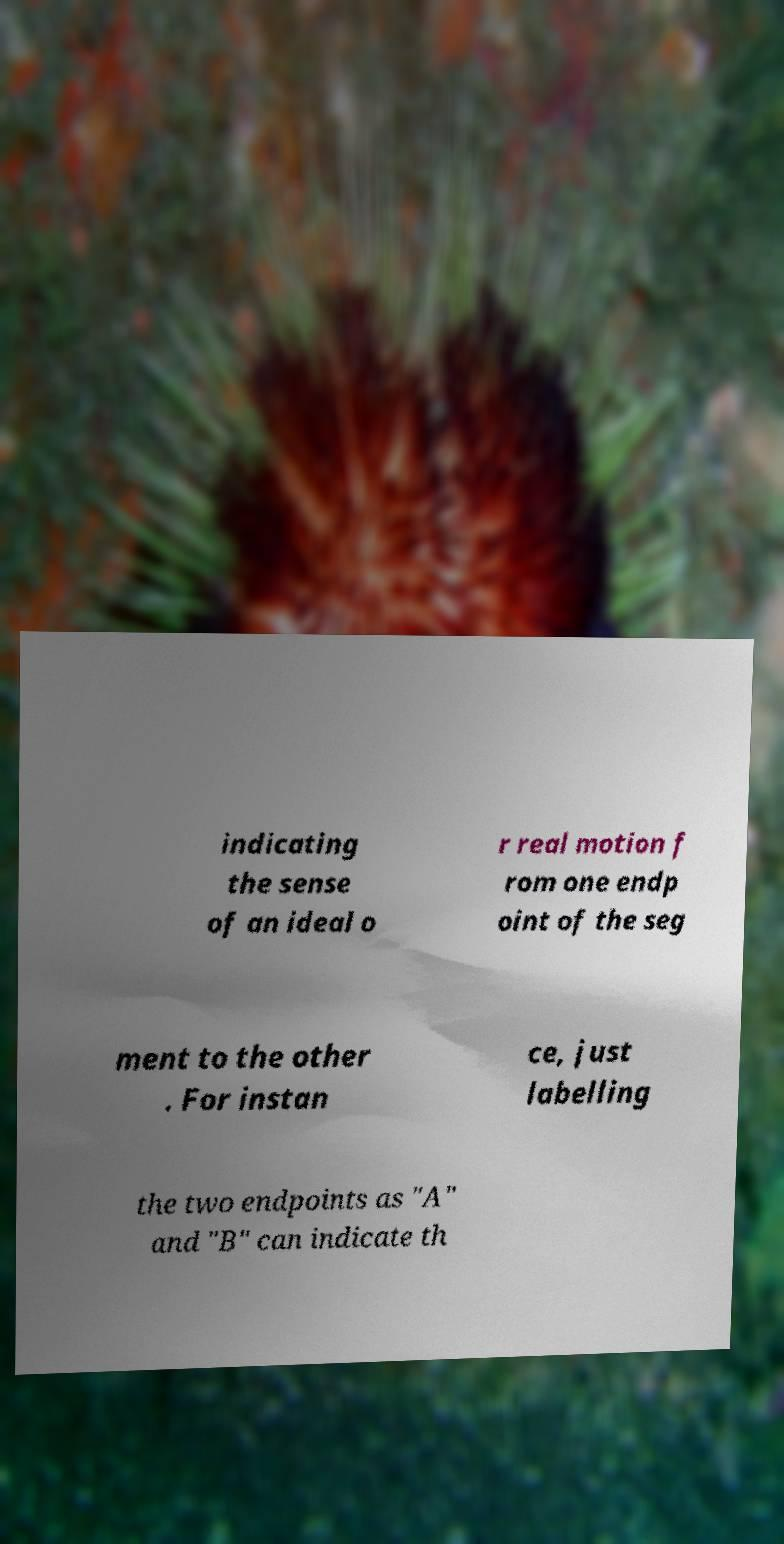Please identify and transcribe the text found in this image. indicating the sense of an ideal o r real motion f rom one endp oint of the seg ment to the other . For instan ce, just labelling the two endpoints as "A" and "B" can indicate th 